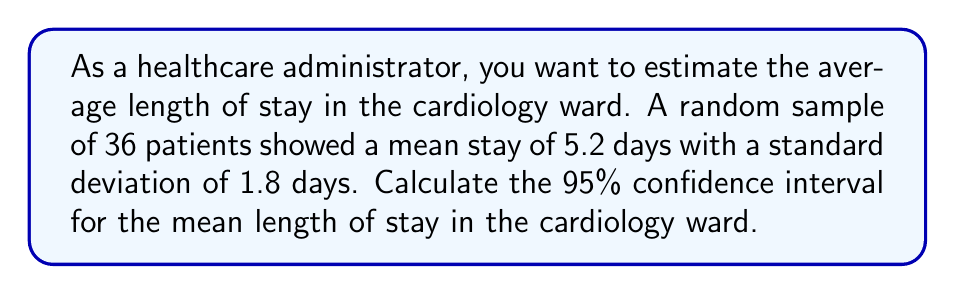Show me your answer to this math problem. Let's approach this step-by-step:

1) We're given:
   - Sample size (n) = 36
   - Sample mean ($\bar{x}$) = 5.2 days
   - Sample standard deviation (s) = 1.8 days
   - Confidence level = 95%

2) For a 95% confidence interval, we use a z-score of 1.96 (assuming normal distribution).

3) The formula for the confidence interval is:

   $$\bar{x} \pm z \cdot \frac{s}{\sqrt{n}}$$

4) Let's calculate the standard error (SE):

   $$SE = \frac{s}{\sqrt{n}} = \frac{1.8}{\sqrt{36}} = \frac{1.8}{6} = 0.3$$

5) Now, let's calculate the margin of error:

   $$\text{Margin of Error} = z \cdot SE = 1.96 \cdot 0.3 = 0.588$$

6) Finally, we can calculate the confidence interval:

   Lower bound: $5.2 - 0.588 = 4.612$
   Upper bound: $5.2 + 0.588 = 5.788$

7) Rounding to two decimal places:

   95% CI: (4.61, 5.79)

This means we can be 95% confident that the true population mean length of stay in the cardiology ward is between 4.61 and 5.79 days.
Answer: (4.61, 5.79) days 